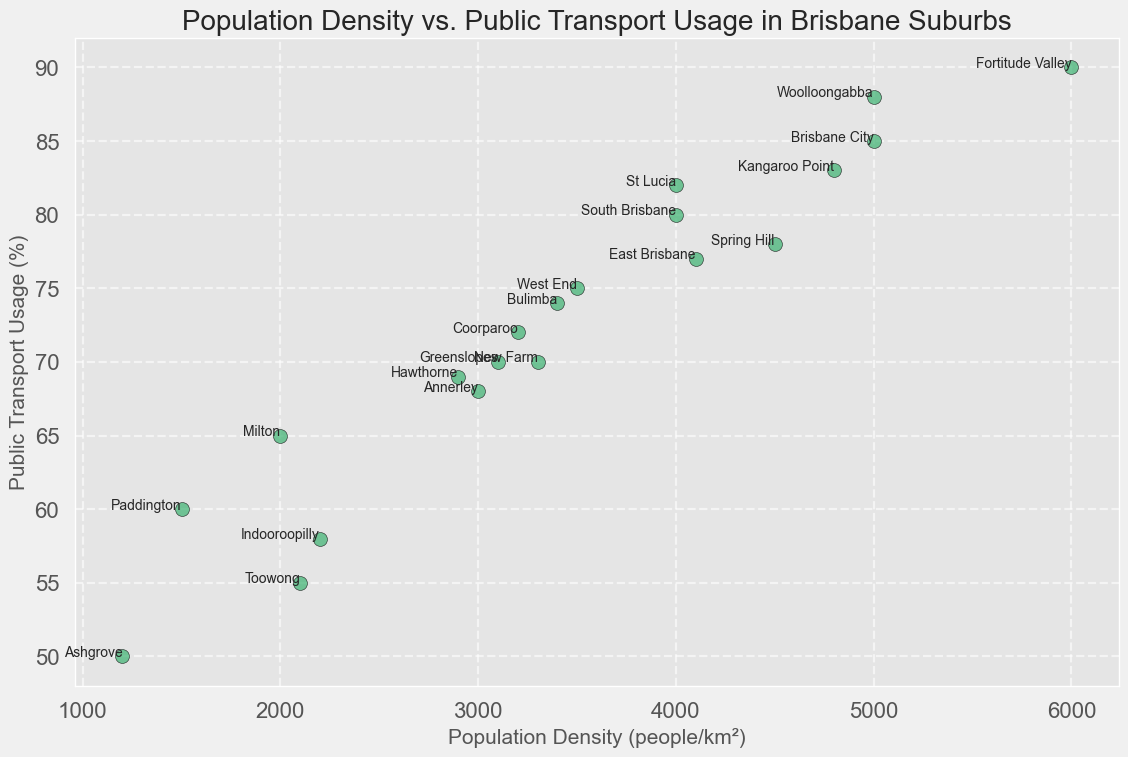What's the population density of the suburb with the highest public transport usage? Identify the point with the highest y-axis value (public transport usage), which is 90% at Fortitude Valley. Check its corresponding x-axis value (population density), which is 6000.
Answer: 6000 What is the average public transport usage in suburbs with a population density greater than 4000? First, identify the suburbs with population density greater than 4000 (Brisbane City, Fortitude Valley, Spring Hill, St Lucia, Woolloongabba, Kangaroo Point, East Brisbane). Their public transport usage values are 85, 90, 78, 82, 88, 83, 77. Calculate the average: (85 + 90 + 78 + 82 + 88 + 83 + 77) / 7 = 83.29.
Answer: 83.29 Which suburb has the lowest public transport usage, and what is its population density? Identify the point with the lowest y-axis value (public transport usage), which is 50% at Ashgrove. Check its corresponding x-axis value (population density), which is 1200.
Answer: Ashgrove, 1200 What is the difference in public transport usage between Brisbane City and Milton? Check the y-axis values for Brisbane City (85) and Milton (65). The difference is 85 - 65 = 20.
Answer: 20 Are there any suburbs that have the same public transport usage? If so, name them. Check for points with identical y-axis values. Greenslopes and New Farm both have 70%.
Answer: Greenslopes, New Farm In which suburb does public transport usage exceed 80% but has a population density less than 4000? Identify points where y-axis value (public transport usage) exceeds 80 and x-axis value (population density) is less than 4000. St Lucia meets these criteria with public transport usage of 82% and population density of 4000*.
Answer: (None, as St Lucia has exactly 4000, not less than 4000) What is the combined population density of South Brisbane and East Brisbane? Check the x-axis values for South Brisbane (4000) and East Brisbane (4100). The combined total is 4000 + 4100 = 8100.
Answer: 8100 Which suburb with a public transport usage above 75% has the smallest population density? Identify points with y-axis value (public transport usage) above 75%. The eligible points have population densities of Fortitude Valley (6000), Brisbane City (5000), St Lucia (4000), Woolloongabba (5000), Kangaroo Point (4800), East Brisbane (4100), Spring Hill (4500). Spring Hill (4500) is the smallest.
Answer: Spring Hill What range of public transport usage is observed in the data? Identify the minimum and maximum y-axis values (public transport usage), which are 50% (Ashgrove) and 90% (Fortitude Valley). The range is 90 - 50 = 40.
Answer: 40 Which suburb has the highest and which has the lowest population density among those with more than 70% public transport usage? Identify points with y-axis values (public transport usage) above 70%. The eligible points have population densities of Fortitude Valley (6000), Brisbane City (5000), South Brisbane (4000), St Lucia (4000), Woolloongabba (5000), Kangaroo Point (4800), East Brisbane (4100), West End (3500), Coorparoo (3200), Bulimba (3400). Highest is Fortitude Valley (6000). Lowest is Coorparoo (3200).
Answer: Fortitude Valley, Coorparoo 